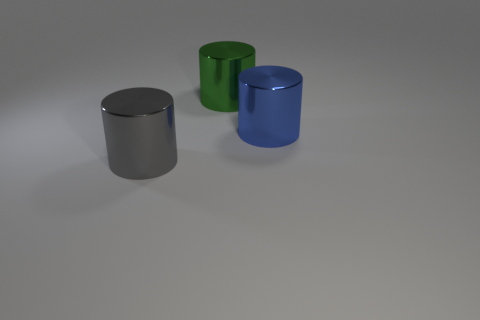What materials do the cylinders in the image look like they are made of? The cylinders in the image seem to have a smooth, reflective surface, suggesting they are possibly made of metal with different finishings, giving them a sleek appearance. 